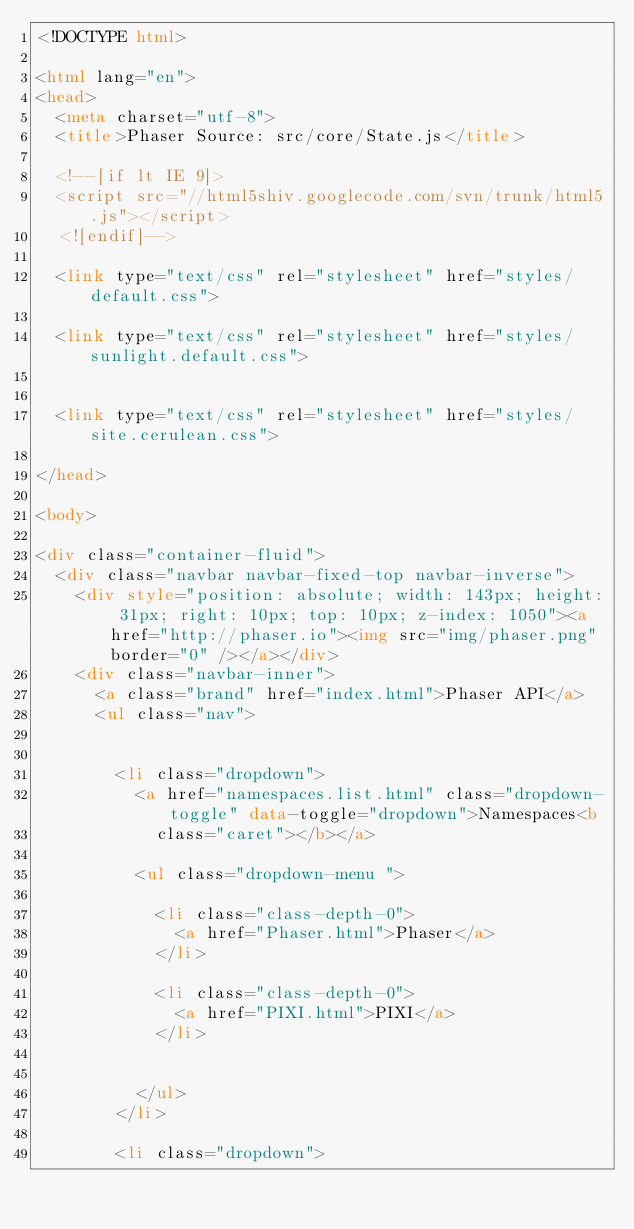<code> <loc_0><loc_0><loc_500><loc_500><_HTML_><!DOCTYPE html>

<html lang="en">
<head>
	<meta charset="utf-8">
	<title>Phaser Source: src/core/State.js</title>

	<!--[if lt IE 9]>
	<script src="//html5shiv.googlecode.com/svn/trunk/html5.js"></script>
	<![endif]-->

	<link type="text/css" rel="stylesheet" href="styles/default.css">

	<link type="text/css" rel="stylesheet" href="styles/sunlight.default.css">

	
	<link type="text/css" rel="stylesheet" href="styles/site.cerulean.css">
	
</head>

<body>

<div class="container-fluid">
	<div class="navbar navbar-fixed-top navbar-inverse">
		<div style="position: absolute; width: 143px; height: 31px; right: 10px; top: 10px; z-index: 1050"><a href="http://phaser.io"><img src="img/phaser.png" border="0" /></a></div>
		<div class="navbar-inner">
			<a class="brand" href="index.html">Phaser API</a>
			<ul class="nav">

				
				<li class="dropdown">
					<a href="namespaces.list.html" class="dropdown-toggle" data-toggle="dropdown">Namespaces<b
						class="caret"></b></a>

					<ul class="dropdown-menu ">
						
						<li class="class-depth-0">
							<a href="Phaser.html">Phaser</a>
						</li>
						
						<li class="class-depth-0">
							<a href="PIXI.html">PIXI</a>
						</li>
						

					</ul>
				</li>
				
				<li class="dropdown"></code> 